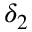Convert formula to latex. <formula><loc_0><loc_0><loc_500><loc_500>\delta _ { 2 }</formula> 